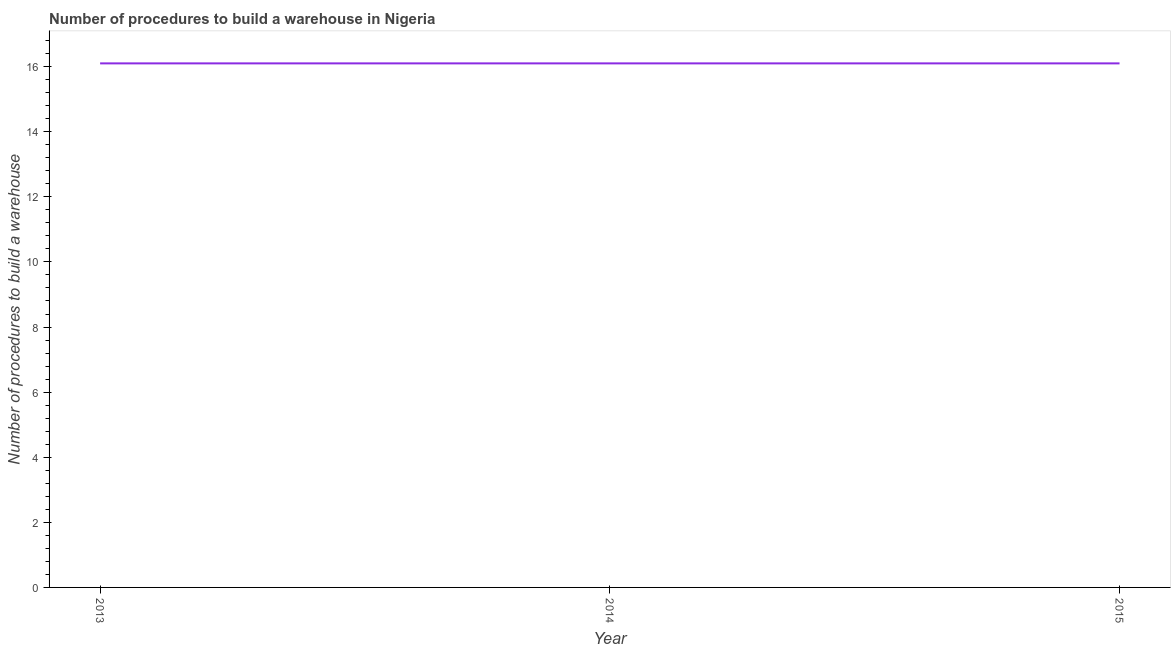What is the number of procedures to build a warehouse in 2014?
Offer a very short reply. 16.1. Across all years, what is the maximum number of procedures to build a warehouse?
Provide a short and direct response. 16.1. In which year was the number of procedures to build a warehouse minimum?
Make the answer very short. 2013. What is the sum of the number of procedures to build a warehouse?
Your answer should be compact. 48.3. What is the median number of procedures to build a warehouse?
Your answer should be very brief. 16.1. In how many years, is the number of procedures to build a warehouse greater than 2 ?
Offer a very short reply. 3. Do a majority of the years between 2015 and 2014 (inclusive) have number of procedures to build a warehouse greater than 6.4 ?
Your response must be concise. No. What is the difference between the highest and the second highest number of procedures to build a warehouse?
Ensure brevity in your answer.  0. How many lines are there?
Your answer should be compact. 1. How many years are there in the graph?
Offer a terse response. 3. Are the values on the major ticks of Y-axis written in scientific E-notation?
Provide a succinct answer. No. Does the graph contain any zero values?
Provide a succinct answer. No. What is the title of the graph?
Offer a terse response. Number of procedures to build a warehouse in Nigeria. What is the label or title of the X-axis?
Ensure brevity in your answer.  Year. What is the label or title of the Y-axis?
Give a very brief answer. Number of procedures to build a warehouse. What is the difference between the Number of procedures to build a warehouse in 2014 and 2015?
Keep it short and to the point. 0. What is the ratio of the Number of procedures to build a warehouse in 2013 to that in 2014?
Provide a short and direct response. 1. 